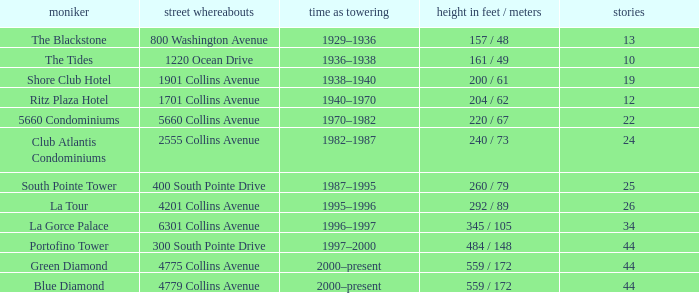Can you parse all the data within this table? {'header': ['moniker', 'street whereabouts', 'time as towering', 'height in feet / meters', 'stories'], 'rows': [['The Blackstone', '800 Washington Avenue', '1929–1936', '157 / 48', '13'], ['The Tides', '1220 Ocean Drive', '1936–1938', '161 / 49', '10'], ['Shore Club Hotel', '1901 Collins Avenue', '1938–1940', '200 / 61', '19'], ['Ritz Plaza Hotel', '1701 Collins Avenue', '1940–1970', '204 / 62', '12'], ['5660 Condominiums', '5660 Collins Avenue', '1970–1982', '220 / 67', '22'], ['Club Atlantis Condominiums', '2555 Collins Avenue', '1982–1987', '240 / 73', '24'], ['South Pointe Tower', '400 South Pointe Drive', '1987–1995', '260 / 79', '25'], ['La Tour', '4201 Collins Avenue', '1995–1996', '292 / 89', '26'], ['La Gorce Palace', '6301 Collins Avenue', '1996–1997', '345 / 105', '34'], ['Portofino Tower', '300 South Pointe Drive', '1997–2000', '484 / 148', '44'], ['Green Diamond', '4775 Collins Avenue', '2000–present', '559 / 172', '44'], ['Blue Diamond', '4779 Collins Avenue', '2000–present', '559 / 172', '44']]} How many years was the building with 24 floors the tallest? 1982–1987. 